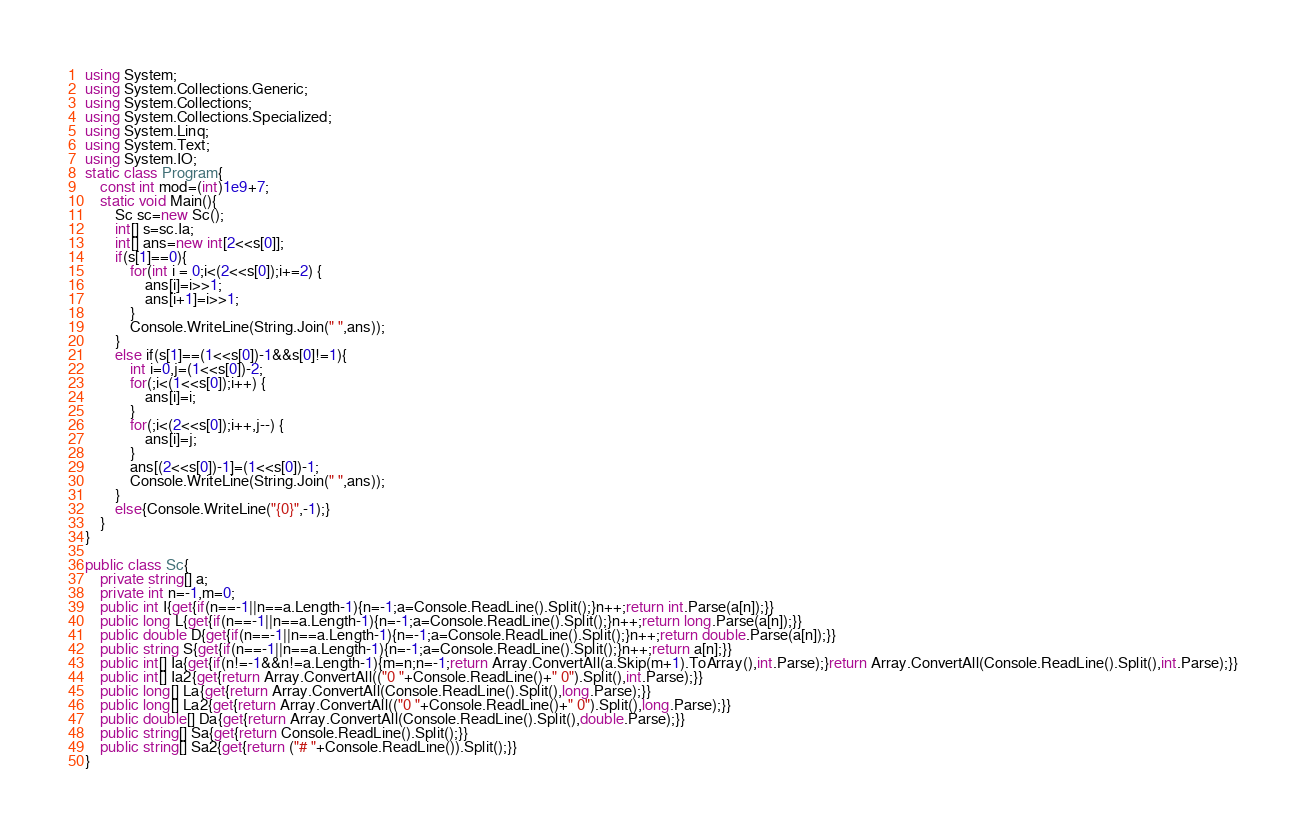Convert code to text. <code><loc_0><loc_0><loc_500><loc_500><_C#_>using System;
using System.Collections.Generic;
using System.Collections;
using System.Collections.Specialized;
using System.Linq;
using System.Text;
using System.IO;
static class Program{
	const int mod=(int)1e9+7;
	static void Main(){
		Sc sc=new Sc();
		int[] s=sc.Ia;
		int[] ans=new int[2<<s[0]];
		if(s[1]==0){
			for(int i = 0;i<(2<<s[0]);i+=2) {
				ans[i]=i>>1;
				ans[i+1]=i>>1;
			}
			Console.WriteLine(String.Join(" ",ans));
		}
		else if(s[1]==(1<<s[0])-1&&s[0]!=1){
			int i=0,j=(1<<s[0])-2;
			for(;i<(1<<s[0]);i++) {
				ans[i]=i;
			}
			for(;i<(2<<s[0]);i++,j--) {
				ans[i]=j;
			}
			ans[(2<<s[0])-1]=(1<<s[0])-1;
			Console.WriteLine(String.Join(" ",ans));
		}
		else{Console.WriteLine("{0}",-1);}
	}
}

public class Sc{
	private string[] a;
	private int n=-1,m=0;
	public int I{get{if(n==-1||n==a.Length-1){n=-1;a=Console.ReadLine().Split();}n++;return int.Parse(a[n]);}}
	public long L{get{if(n==-1||n==a.Length-1){n=-1;a=Console.ReadLine().Split();}n++;return long.Parse(a[n]);}}
	public double D{get{if(n==-1||n==a.Length-1){n=-1;a=Console.ReadLine().Split();}n++;return double.Parse(a[n]);}}
	public string S{get{if(n==-1||n==a.Length-1){n=-1;a=Console.ReadLine().Split();}n++;return a[n];}}
	public int[] Ia{get{if(n!=-1&&n!=a.Length-1){m=n;n=-1;return Array.ConvertAll(a.Skip(m+1).ToArray(),int.Parse);}return Array.ConvertAll(Console.ReadLine().Split(),int.Parse);}}
	public int[] Ia2{get{return Array.ConvertAll(("0 "+Console.ReadLine()+" 0").Split(),int.Parse);}}
	public long[] La{get{return Array.ConvertAll(Console.ReadLine().Split(),long.Parse);}}
	public long[] La2{get{return Array.ConvertAll(("0 "+Console.ReadLine()+" 0").Split(),long.Parse);}}
	public double[] Da{get{return Array.ConvertAll(Console.ReadLine().Split(),double.Parse);}}
	public string[] Sa{get{return Console.ReadLine().Split();}}
	public string[] Sa2{get{return ("# "+Console.ReadLine()).Split();}}
}</code> 